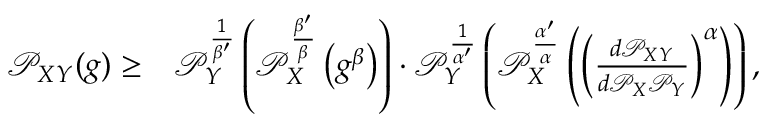Convert formula to latex. <formula><loc_0><loc_0><loc_500><loc_500>\begin{array} { r l } { \mathcal { P } _ { X Y } ( g ) \geq } & { \mathcal { P } _ { Y } ^ { \frac { 1 } { \beta ^ { \prime } } } \left ( \mathcal { P } _ { X } ^ { \frac { \beta ^ { \prime } } { \beta } } \left ( g ^ { \beta } \right ) \right ) \cdot \mathcal { P } _ { Y } ^ { \frac { 1 } { \alpha ^ { \prime } } } \left ( \mathcal { P } _ { X } ^ { \frac { \alpha ^ { \prime } } { \alpha } } \left ( \left ( \frac { d \mathcal { P } _ { X Y } } { d \mathcal { P } _ { X } \mathcal { P } _ { Y } } \right ) ^ { \alpha } \right ) \right ) , } \end{array}</formula> 